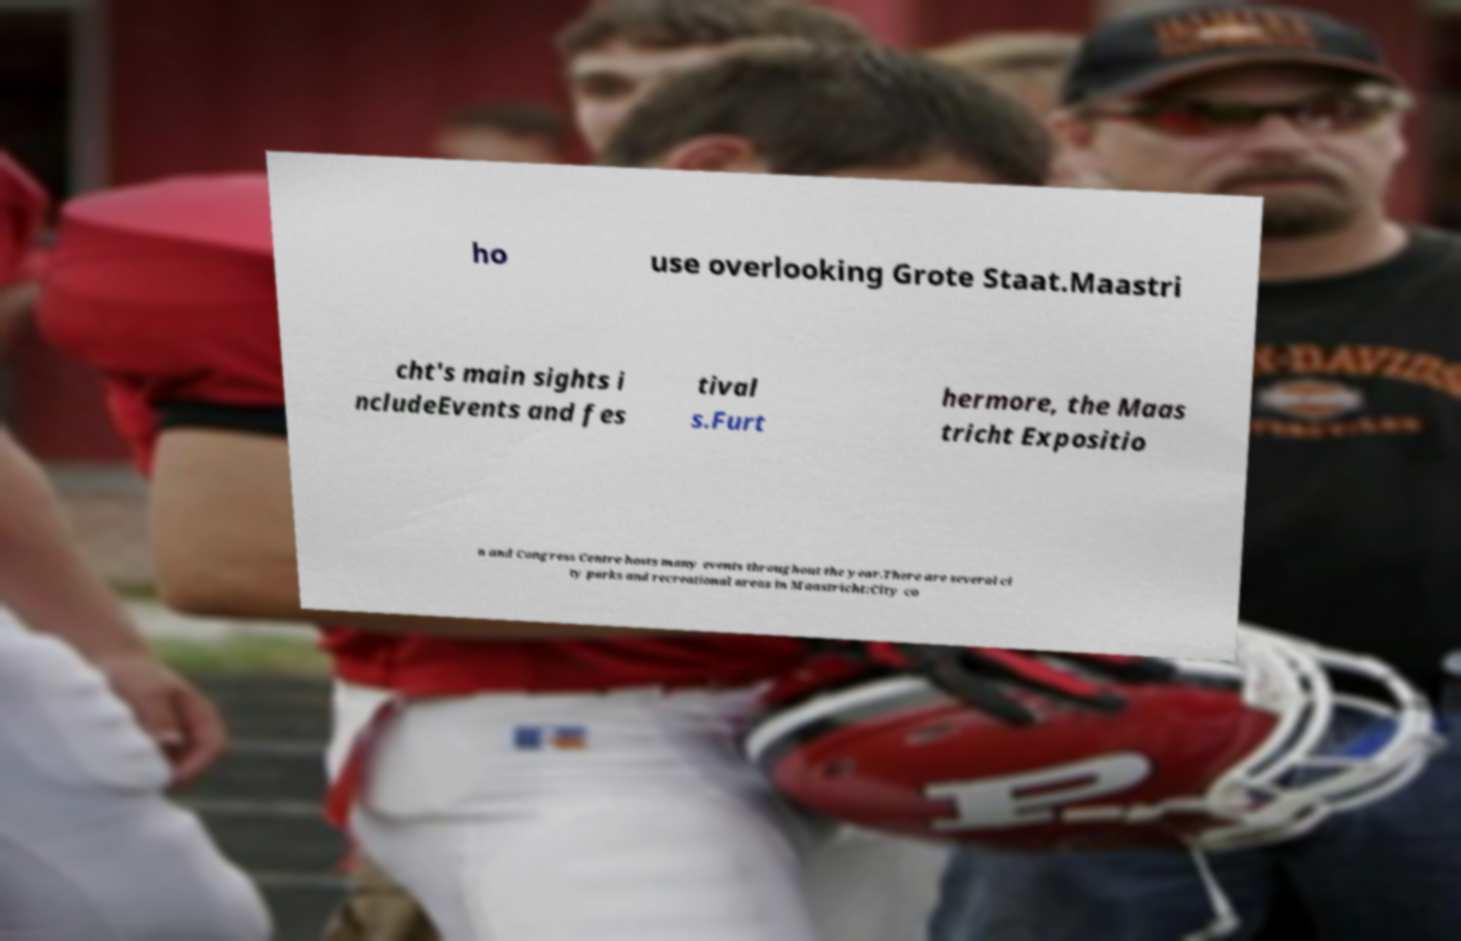Please read and relay the text visible in this image. What does it say? ho use overlooking Grote Staat.Maastri cht's main sights i ncludeEvents and fes tival s.Furt hermore, the Maas tricht Expositio n and Congress Centre hosts many events throughout the year.There are several ci ty parks and recreational areas in Maastricht:City co 